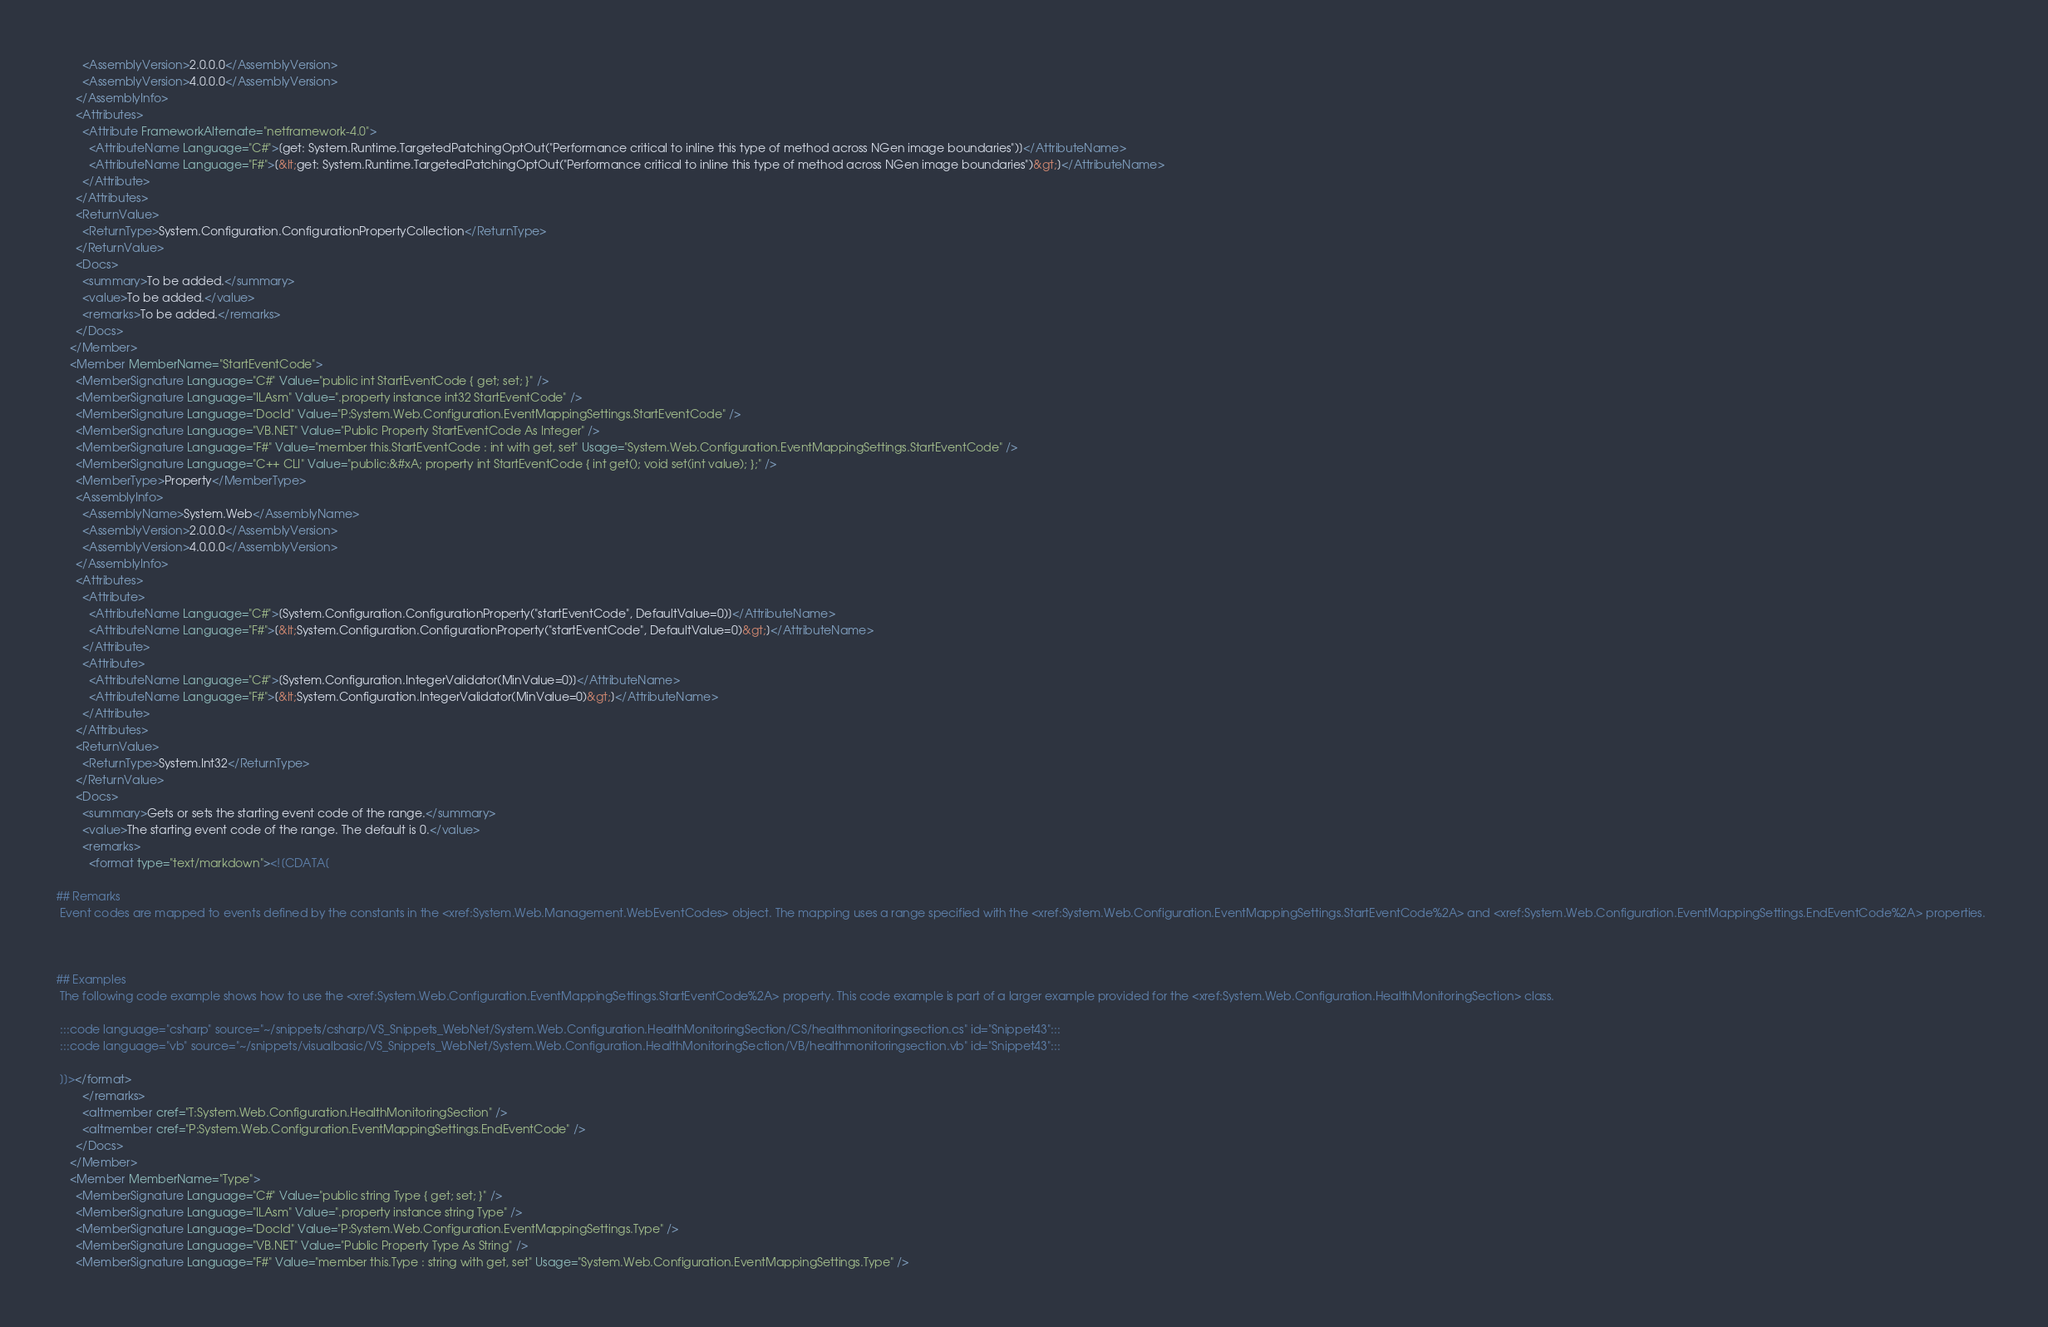<code> <loc_0><loc_0><loc_500><loc_500><_XML_>        <AssemblyVersion>2.0.0.0</AssemblyVersion>
        <AssemblyVersion>4.0.0.0</AssemblyVersion>
      </AssemblyInfo>
      <Attributes>
        <Attribute FrameworkAlternate="netframework-4.0">
          <AttributeName Language="C#">[get: System.Runtime.TargetedPatchingOptOut("Performance critical to inline this type of method across NGen image boundaries")]</AttributeName>
          <AttributeName Language="F#">[&lt;get: System.Runtime.TargetedPatchingOptOut("Performance critical to inline this type of method across NGen image boundaries")&gt;]</AttributeName>
        </Attribute>
      </Attributes>
      <ReturnValue>
        <ReturnType>System.Configuration.ConfigurationPropertyCollection</ReturnType>
      </ReturnValue>
      <Docs>
        <summary>To be added.</summary>
        <value>To be added.</value>
        <remarks>To be added.</remarks>
      </Docs>
    </Member>
    <Member MemberName="StartEventCode">
      <MemberSignature Language="C#" Value="public int StartEventCode { get; set; }" />
      <MemberSignature Language="ILAsm" Value=".property instance int32 StartEventCode" />
      <MemberSignature Language="DocId" Value="P:System.Web.Configuration.EventMappingSettings.StartEventCode" />
      <MemberSignature Language="VB.NET" Value="Public Property StartEventCode As Integer" />
      <MemberSignature Language="F#" Value="member this.StartEventCode : int with get, set" Usage="System.Web.Configuration.EventMappingSettings.StartEventCode" />
      <MemberSignature Language="C++ CLI" Value="public:&#xA; property int StartEventCode { int get(); void set(int value); };" />
      <MemberType>Property</MemberType>
      <AssemblyInfo>
        <AssemblyName>System.Web</AssemblyName>
        <AssemblyVersion>2.0.0.0</AssemblyVersion>
        <AssemblyVersion>4.0.0.0</AssemblyVersion>
      </AssemblyInfo>
      <Attributes>
        <Attribute>
          <AttributeName Language="C#">[System.Configuration.ConfigurationProperty("startEventCode", DefaultValue=0)]</AttributeName>
          <AttributeName Language="F#">[&lt;System.Configuration.ConfigurationProperty("startEventCode", DefaultValue=0)&gt;]</AttributeName>
        </Attribute>
        <Attribute>
          <AttributeName Language="C#">[System.Configuration.IntegerValidator(MinValue=0)]</AttributeName>
          <AttributeName Language="F#">[&lt;System.Configuration.IntegerValidator(MinValue=0)&gt;]</AttributeName>
        </Attribute>
      </Attributes>
      <ReturnValue>
        <ReturnType>System.Int32</ReturnType>
      </ReturnValue>
      <Docs>
        <summary>Gets or sets the starting event code of the range.</summary>
        <value>The starting event code of the range. The default is 0.</value>
        <remarks>
          <format type="text/markdown"><![CDATA[  
  
## Remarks  
 Event codes are mapped to events defined by the constants in the <xref:System.Web.Management.WebEventCodes> object. The mapping uses a range specified with the <xref:System.Web.Configuration.EventMappingSettings.StartEventCode%2A> and <xref:System.Web.Configuration.EventMappingSettings.EndEventCode%2A> properties.  
  
   
  
## Examples  
 The following code example shows how to use the <xref:System.Web.Configuration.EventMappingSettings.StartEventCode%2A> property. This code example is part of a larger example provided for the <xref:System.Web.Configuration.HealthMonitoringSection> class.  
  
 :::code language="csharp" source="~/snippets/csharp/VS_Snippets_WebNet/System.Web.Configuration.HealthMonitoringSection/CS/healthmonitoringsection.cs" id="Snippet43":::
 :::code language="vb" source="~/snippets/visualbasic/VS_Snippets_WebNet/System.Web.Configuration.HealthMonitoringSection/VB/healthmonitoringsection.vb" id="Snippet43":::  
  
 ]]></format>
        </remarks>
        <altmember cref="T:System.Web.Configuration.HealthMonitoringSection" />
        <altmember cref="P:System.Web.Configuration.EventMappingSettings.EndEventCode" />
      </Docs>
    </Member>
    <Member MemberName="Type">
      <MemberSignature Language="C#" Value="public string Type { get; set; }" />
      <MemberSignature Language="ILAsm" Value=".property instance string Type" />
      <MemberSignature Language="DocId" Value="P:System.Web.Configuration.EventMappingSettings.Type" />
      <MemberSignature Language="VB.NET" Value="Public Property Type As String" />
      <MemberSignature Language="F#" Value="member this.Type : string with get, set" Usage="System.Web.Configuration.EventMappingSettings.Type" /></code> 